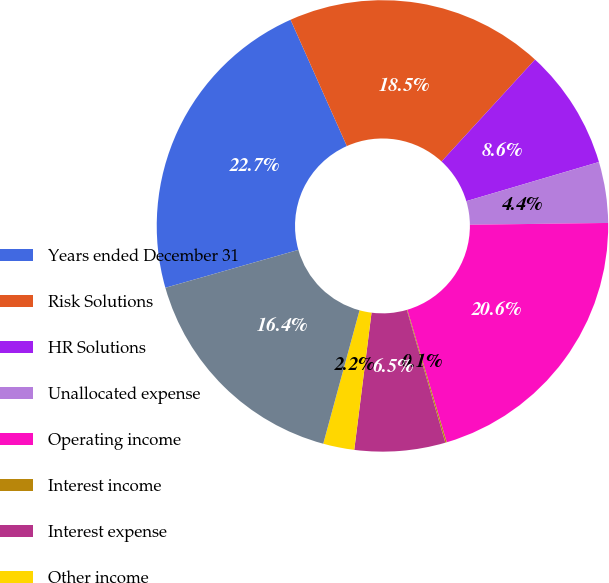<chart> <loc_0><loc_0><loc_500><loc_500><pie_chart><fcel>Years ended December 31<fcel>Risk Solutions<fcel>HR Solutions<fcel>Unallocated expense<fcel>Operating income<fcel>Interest income<fcel>Interest expense<fcel>Other income<fcel>Income before income taxes<nl><fcel>22.75%<fcel>18.49%<fcel>8.62%<fcel>4.36%<fcel>20.62%<fcel>0.1%<fcel>6.49%<fcel>2.23%<fcel>16.36%<nl></chart> 